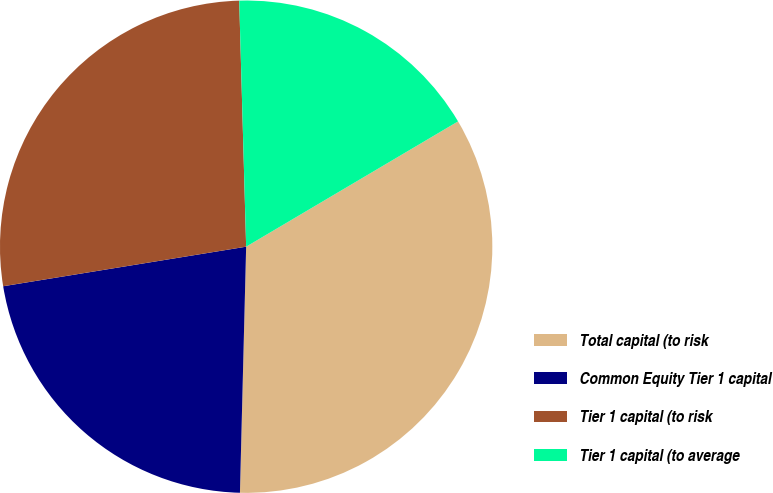Convert chart to OTSL. <chart><loc_0><loc_0><loc_500><loc_500><pie_chart><fcel>Total capital (to risk<fcel>Common Equity Tier 1 capital<fcel>Tier 1 capital (to risk<fcel>Tier 1 capital (to average<nl><fcel>33.9%<fcel>22.03%<fcel>27.12%<fcel>16.95%<nl></chart> 